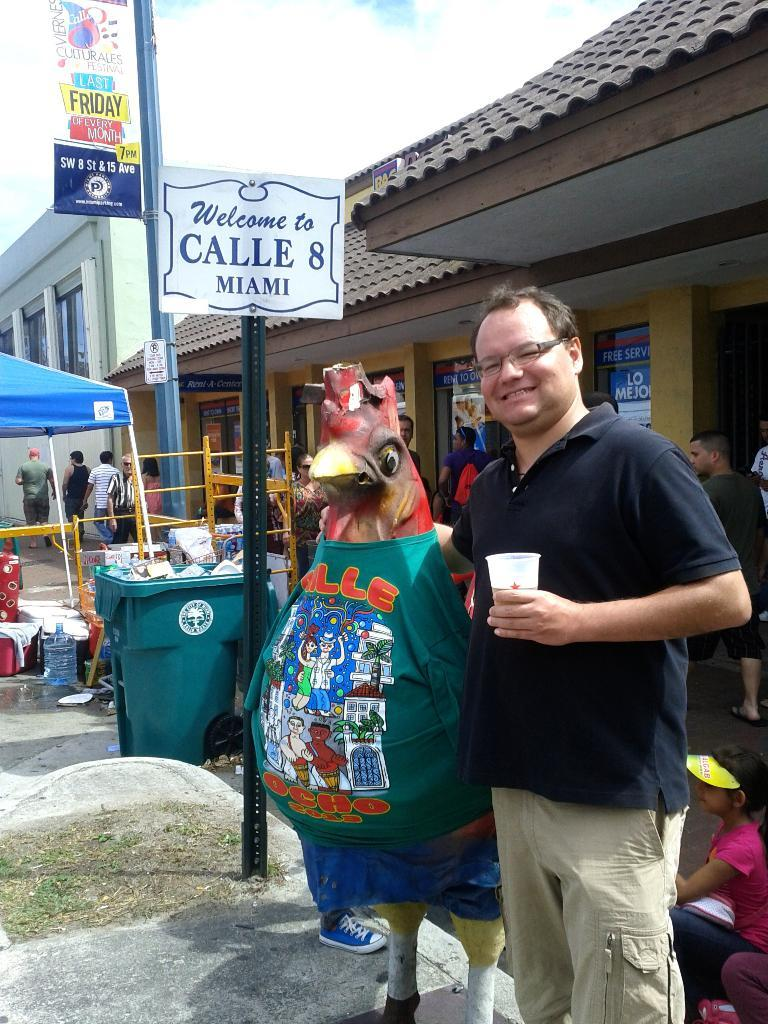<image>
Create a compact narrative representing the image presented. A statue of a chicken stands in front of Calle 8 in Miami. 